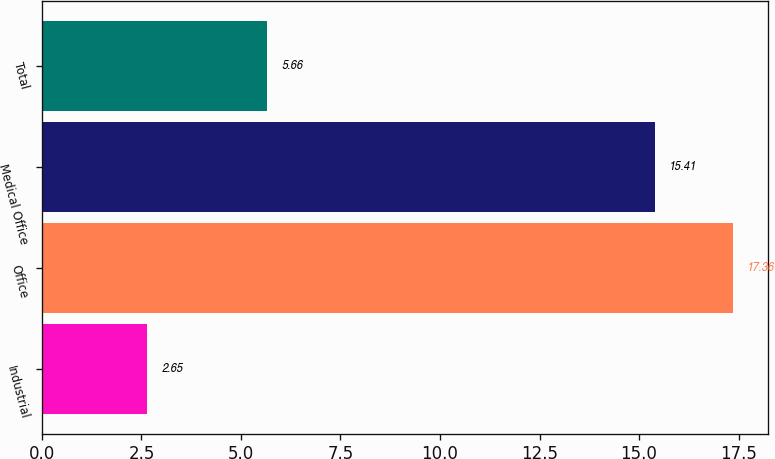Convert chart to OTSL. <chart><loc_0><loc_0><loc_500><loc_500><bar_chart><fcel>Industrial<fcel>Office<fcel>Medical Office<fcel>Total<nl><fcel>2.65<fcel>17.36<fcel>15.41<fcel>5.66<nl></chart> 